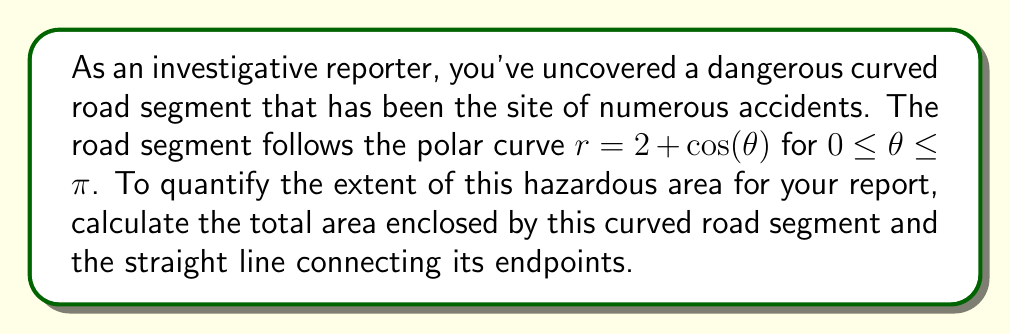Can you answer this question? To solve this problem, we'll use polar integration to find the area enclosed by the curve and the straight line. Here's a step-by-step approach:

1) The area enclosed by a polar curve is given by the formula:

   $$A = \frac{1}{2} \int_a^b [r(\theta)]^2 d\theta$$

2) In this case, $r(\theta) = 2 + \cos(\theta)$ and the limits are from 0 to $\pi$.

3) However, we need to subtract the area of the sector formed by the straight line connecting the endpoints. The equation of this line in polar form is $r = 2$ (as it's a straight line passing through $(2,0)$ and $(-2,0)$ in Cartesian coordinates).

4) So, our complete integral becomes:

   $$A = \frac{1}{2} \int_0^\pi [(2 + \cos(\theta))^2 - 2^2] d\theta$$

5) Expand the squared term:
   
   $$A = \frac{1}{2} \int_0^\pi [4 + 4\cos(\theta) + \cos^2(\theta) - 4] d\theta$$

6) Simplify:

   $$A = \frac{1}{2} \int_0^\pi [4\cos(\theta) + \cos^2(\theta)] d\theta$$

7) Use the identity $\cos^2(\theta) = \frac{1 + \cos(2\theta)}{2}$:

   $$A = \frac{1}{2} \int_0^\pi [4\cos(\theta) + \frac{1 + \cos(2\theta)}{2}] d\theta$$

8) Integrate:

   $$A = \frac{1}{2} [4\sin(\theta) + \frac{\theta}{2} + \frac{\sin(2\theta)}{4}]_0^\pi$$

9) Evaluate the integral:

   $$A = \frac{1}{2} [(0 + \frac{\pi}{2} + 0) - (0 + 0 + 0)] = \frac{\pi}{4}$$

Therefore, the area enclosed by the curved road segment and the straight line is $\frac{\pi}{4}$ square units.
Answer: $\frac{\pi}{4}$ square units 